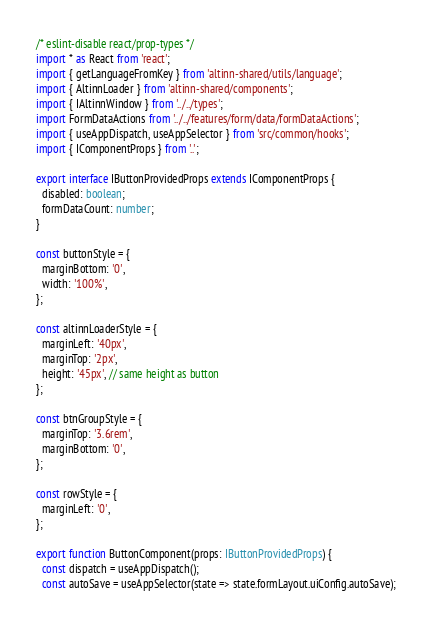Convert code to text. <code><loc_0><loc_0><loc_500><loc_500><_TypeScript_>/* eslint-disable react/prop-types */
import * as React from 'react';
import { getLanguageFromKey } from 'altinn-shared/utils/language';
import { AltinnLoader } from 'altinn-shared/components';
import { IAltinnWindow } from '../../types';
import FormDataActions from '../../features/form/data/formDataActions';
import { useAppDispatch, useAppSelector } from 'src/common/hooks';
import { IComponentProps } from '..';

export interface IButtonProvidedProps extends IComponentProps {
  disabled: boolean;
  formDataCount: number;
}

const buttonStyle = {
  marginBottom: '0',
  width: '100%',
};

const altinnLoaderStyle = {
  marginLeft: '40px',
  marginTop: '2px',
  height: '45px', // same height as button
};

const btnGroupStyle = {
  marginTop: '3.6rem',
  marginBottom: '0',
};

const rowStyle = {
  marginLeft: '0',
};

export function ButtonComponent(props: IButtonProvidedProps) {
  const dispatch = useAppDispatch();
  const autoSave = useAppSelector(state => state.formLayout.uiConfig.autoSave);</code> 